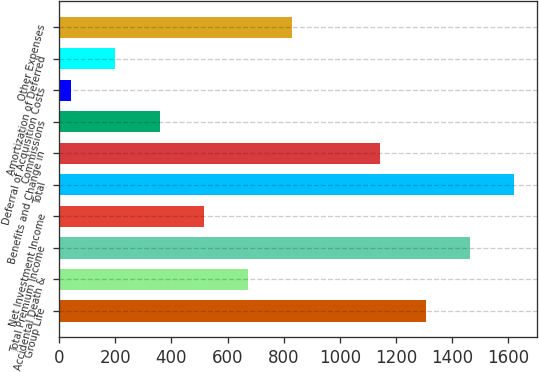Convert chart. <chart><loc_0><loc_0><loc_500><loc_500><bar_chart><fcel>Group Life<fcel>Accidental Death &<fcel>Total Premium Income<fcel>Net Investment Income<fcel>Total<fcel>Benefits and Change in<fcel>Commissions<fcel>Deferral of Acquisition Costs<fcel>Amortization of Deferred<fcel>Other Expenses<nl><fcel>1306.8<fcel>672.46<fcel>1464.24<fcel>515.02<fcel>1621.68<fcel>1144.78<fcel>357.58<fcel>42.7<fcel>200.14<fcel>829.9<nl></chart> 